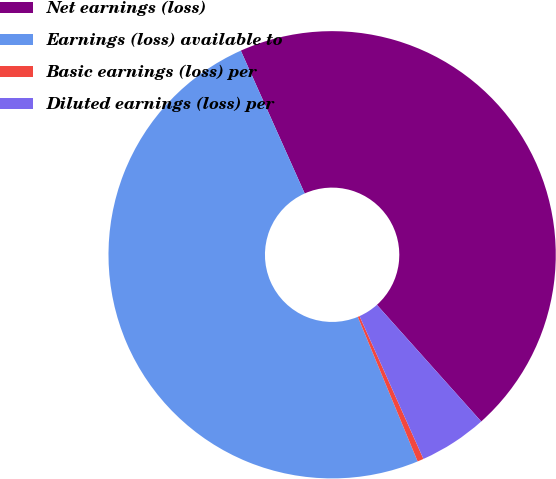Convert chart. <chart><loc_0><loc_0><loc_500><loc_500><pie_chart><fcel>Net earnings (loss)<fcel>Earnings (loss) available to<fcel>Basic earnings (loss) per<fcel>Diluted earnings (loss) per<nl><fcel>45.08%<fcel>49.55%<fcel>0.45%<fcel>4.92%<nl></chart> 